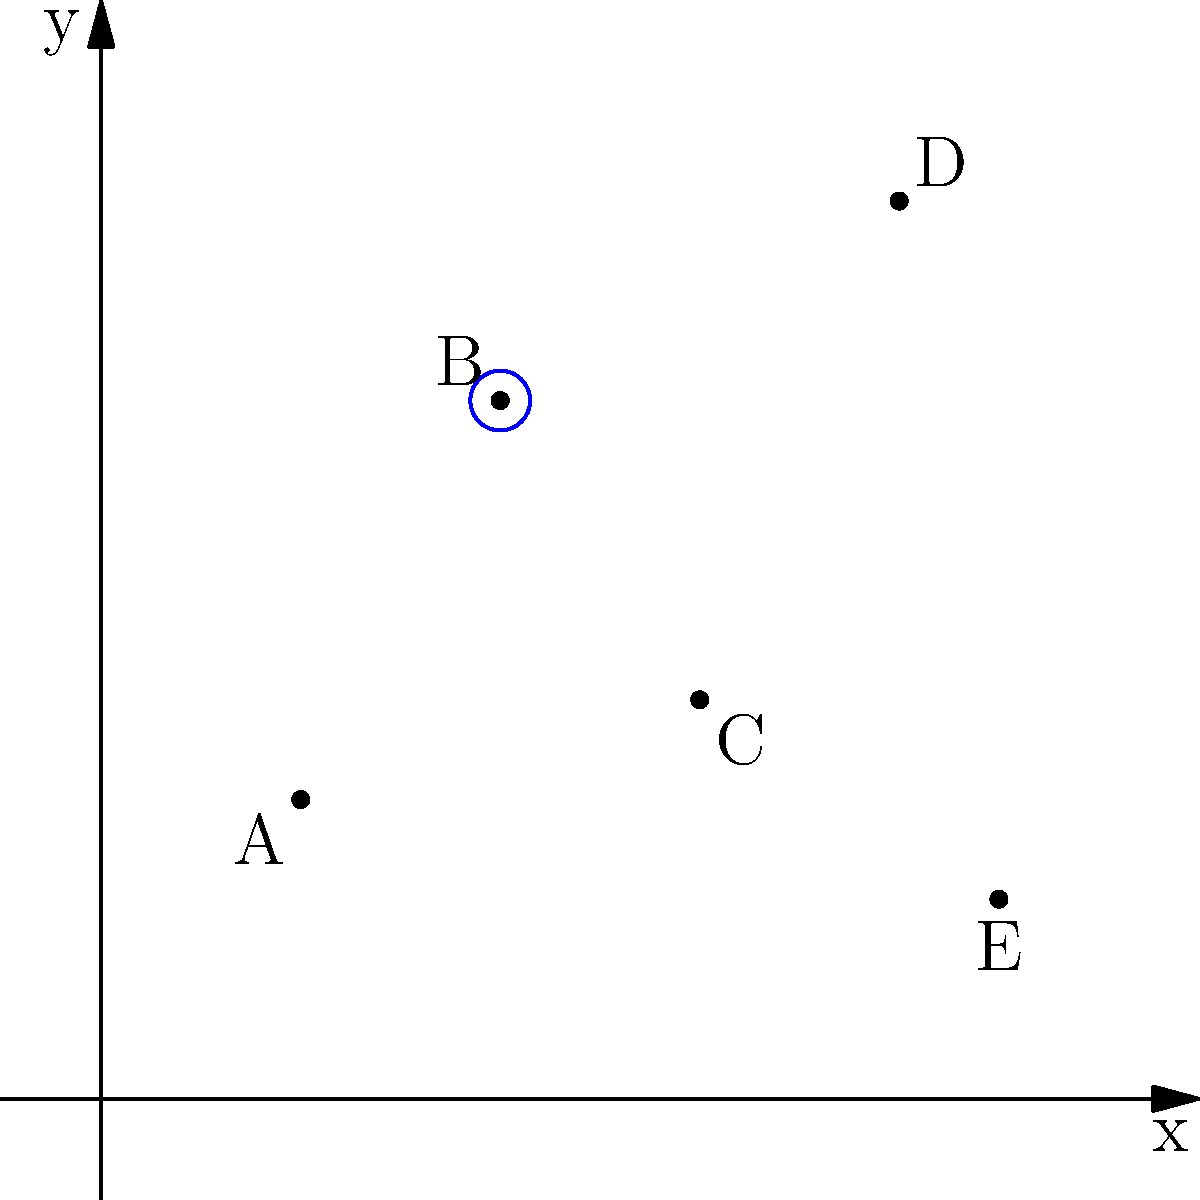The coordinate plane represents different locations in a city, with points indicating areas of high population density. Which location would be the most suitable for a new homeless shelter to maximize its impact on the homeless population? To determine the optimal location for a new homeless shelter, we need to consider the following factors:

1. Population density: Higher density areas are likely to have more homeless individuals.
2. Centrality: A central location allows easier access from multiple areas.
3. Proximity to other high-density areas: Being close to other populated areas increases the shelter's reach.

Let's analyze each point:

A (2,3): Low population density and not central.
B (4,7): High population density and relatively central.
C (6,4): Moderate population density and central.
D (8,9): High population density but not central.
E (9,2): Low population density and not central.

Point B (4,7) is the most suitable because:
1. It has high population density.
2. It's centrally located, making it accessible from other areas.
3. It's close to other high-density areas (like D), extending its impact.

The blue circle around point B visually emphasizes its optimal position relative to other points.
Answer: B (4,7) 